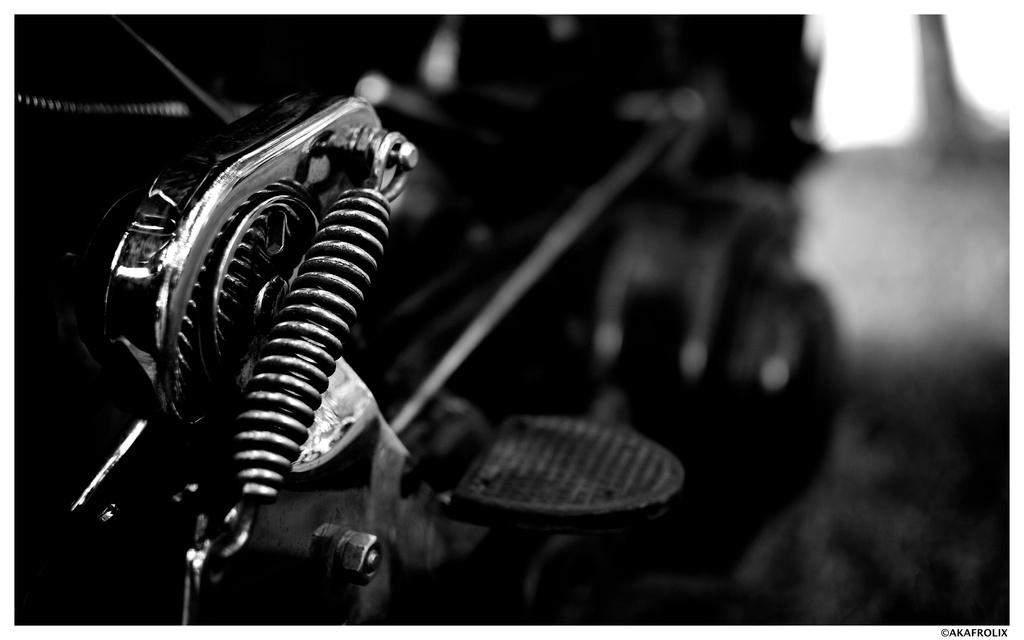What is the main subject on the left side of the image? There is a spring stainless steel of a bike on the left side of the image. What color scheme is used in the image? The image is in black and white color. How many sisters are present in the image? There are no sisters present in the image, as it features a spring stainless steel of a bike. What day of the week is depicted in the image? The image does not depict a specific day of the week, as it is a black and white image of a bike. 